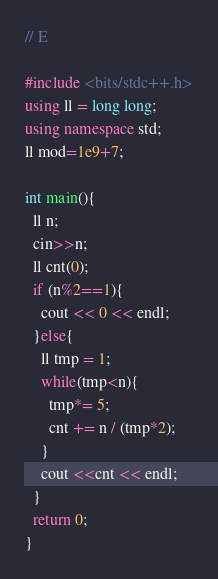Convert code to text. <code><loc_0><loc_0><loc_500><loc_500><_C++_>// E

#include <bits/stdc++.h>
using ll = long long;
using namespace std;
ll mod=1e9+7;

int main(){
  ll n;
  cin>>n;
  ll cnt(0);
  if (n%2==1){
    cout << 0 << endl;
  }else{
    ll tmp = 1;
    while(tmp<n){
      tmp*= 5;
      cnt += n / (tmp*2);
    }
    cout <<cnt << endl;
  }
  return 0;
}
</code> 